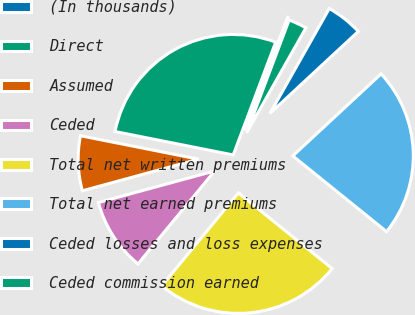<chart> <loc_0><loc_0><loc_500><loc_500><pie_chart><fcel>(In thousands)<fcel>Direct<fcel>Assumed<fcel>Ceded<fcel>Total net written premiums<fcel>Total net earned premiums<fcel>Ceded losses and loss expenses<fcel>Ceded commission earned<nl><fcel>0.01%<fcel>27.61%<fcel>7.34%<fcel>9.79%<fcel>25.17%<fcel>22.72%<fcel>4.9%<fcel>2.45%<nl></chart> 